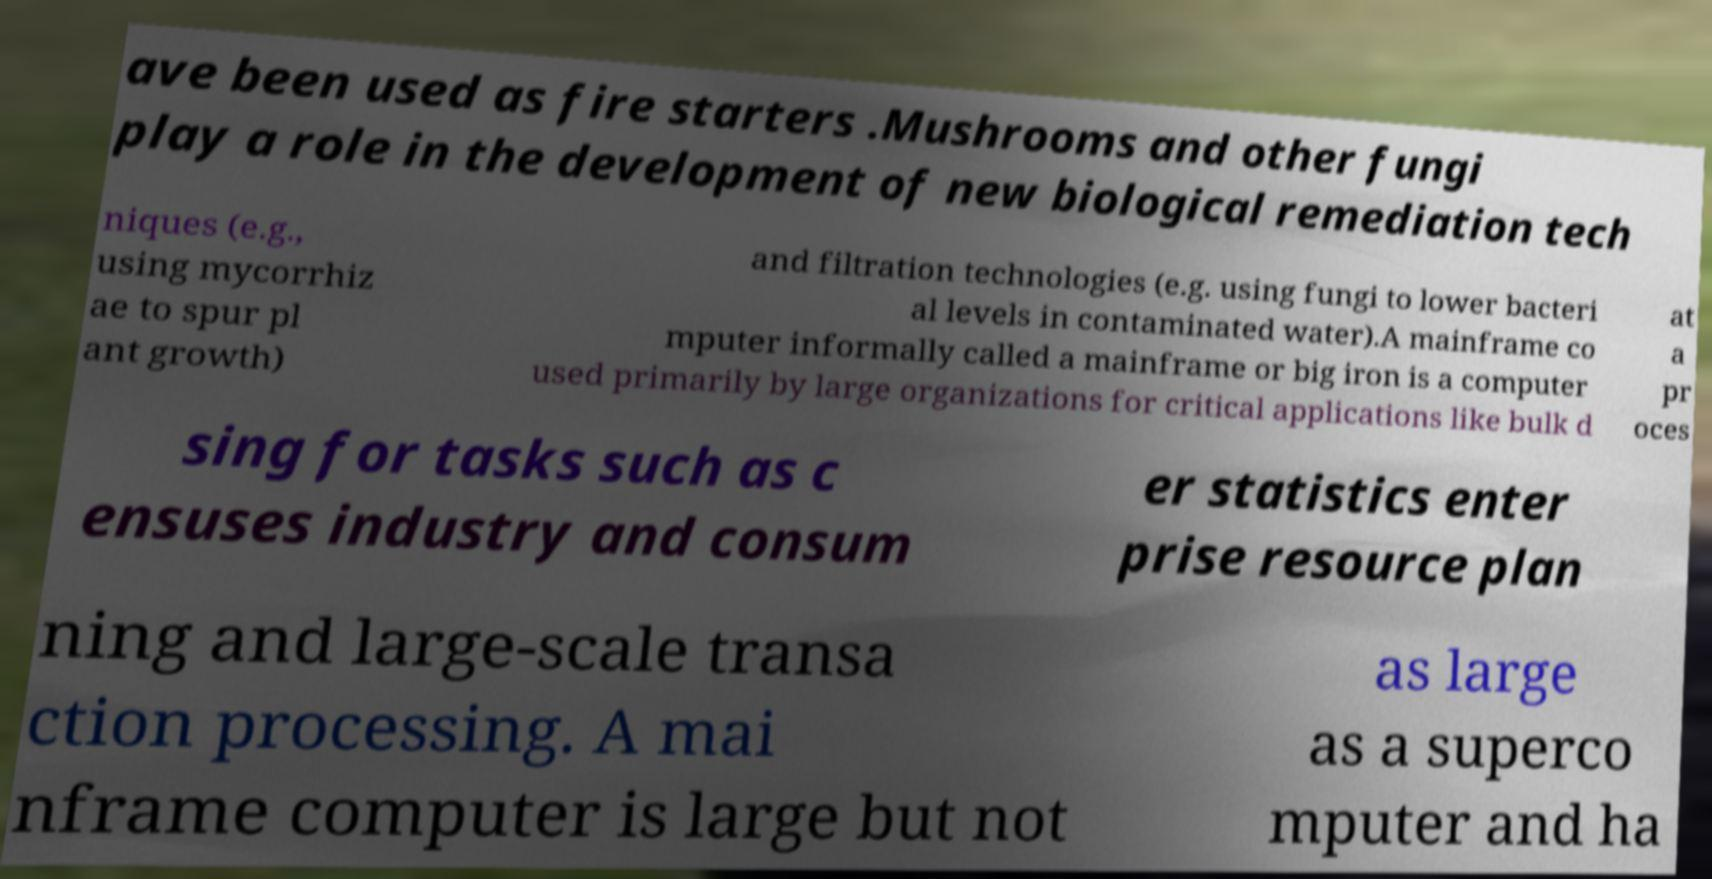Please read and relay the text visible in this image. What does it say? ave been used as fire starters .Mushrooms and other fungi play a role in the development of new biological remediation tech niques (e.g., using mycorrhiz ae to spur pl ant growth) and filtration technologies (e.g. using fungi to lower bacteri al levels in contaminated water).A mainframe co mputer informally called a mainframe or big iron is a computer used primarily by large organizations for critical applications like bulk d at a pr oces sing for tasks such as c ensuses industry and consum er statistics enter prise resource plan ning and large-scale transa ction processing. A mai nframe computer is large but not as large as a superco mputer and ha 